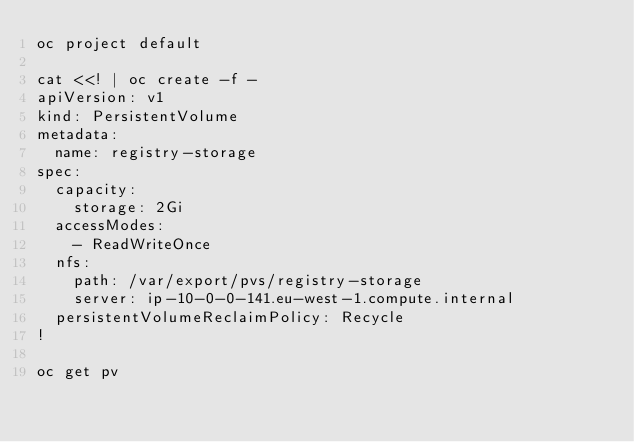Convert code to text. <code><loc_0><loc_0><loc_500><loc_500><_Bash_>oc project default

cat <<! | oc create -f -
apiVersion: v1
kind: PersistentVolume
metadata:
  name: registry-storage
spec:
  capacity:
    storage: 2Gi
  accessModes:
    - ReadWriteOnce
  nfs:
    path: /var/export/pvs/registry-storage
    server: ip-10-0-0-141.eu-west-1.compute.internal
  persistentVolumeReclaimPolicy: Recycle
!

oc get pv

</code> 